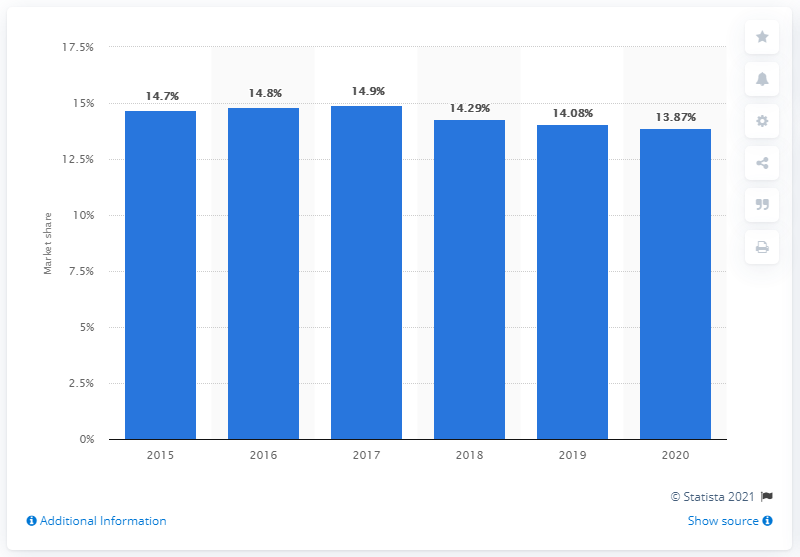Identify some key points in this picture. In 2020, Ford's market share in the U.S. was 13.87%. 